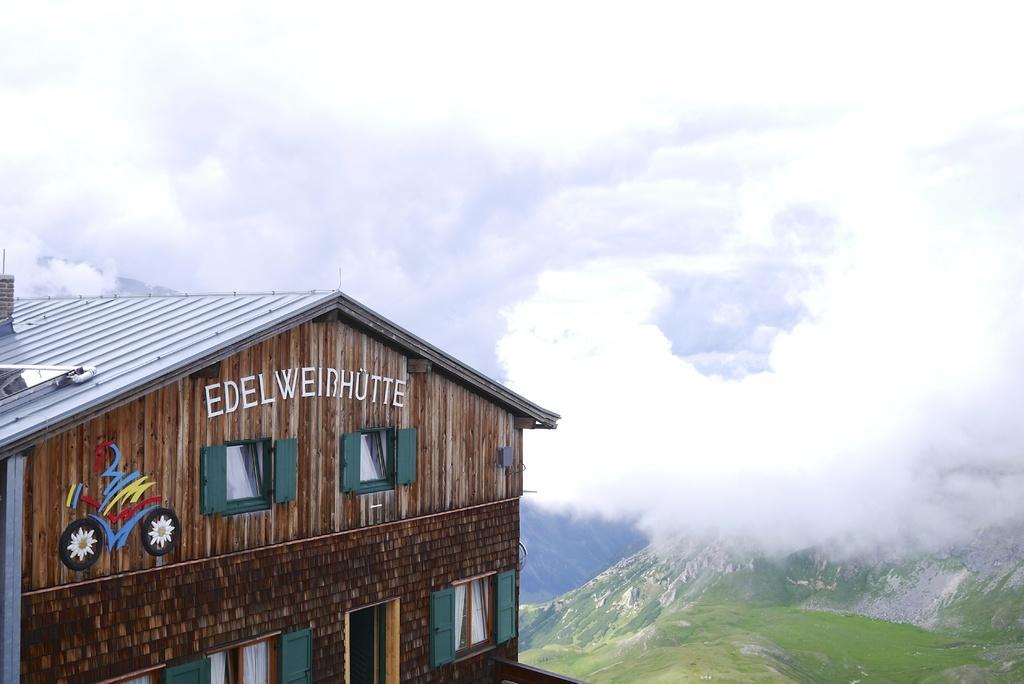Can you describe this image briefly? On the left side of the image we can see a building, windows, door, roof and text on the wall. In the background of the image we can see the clouds in the sky. At the bottom of the image we can see the hills and grass. 